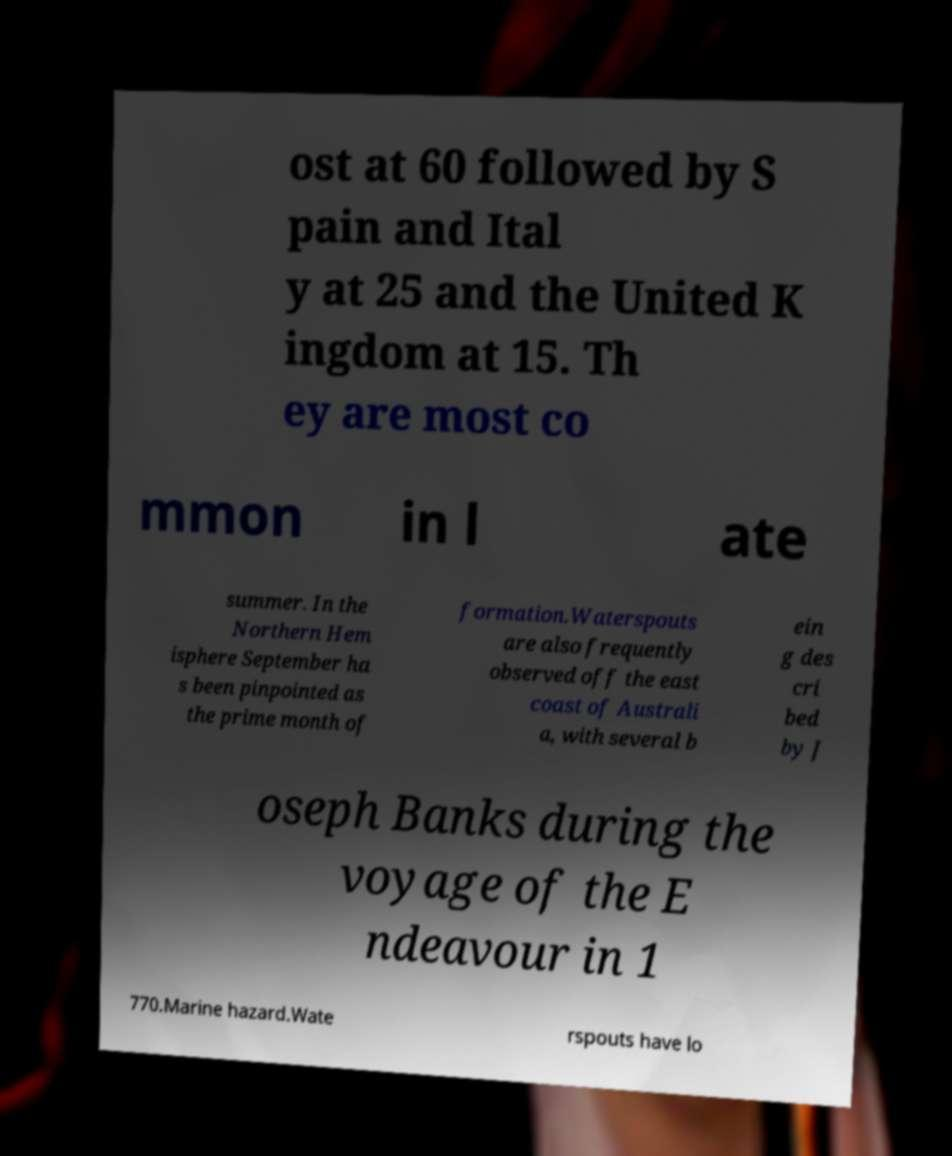For documentation purposes, I need the text within this image transcribed. Could you provide that? ost at 60 followed by S pain and Ital y at 25 and the United K ingdom at 15. Th ey are most co mmon in l ate summer. In the Northern Hem isphere September ha s been pinpointed as the prime month of formation.Waterspouts are also frequently observed off the east coast of Australi a, with several b ein g des cri bed by J oseph Banks during the voyage of the E ndeavour in 1 770.Marine hazard.Wate rspouts have lo 